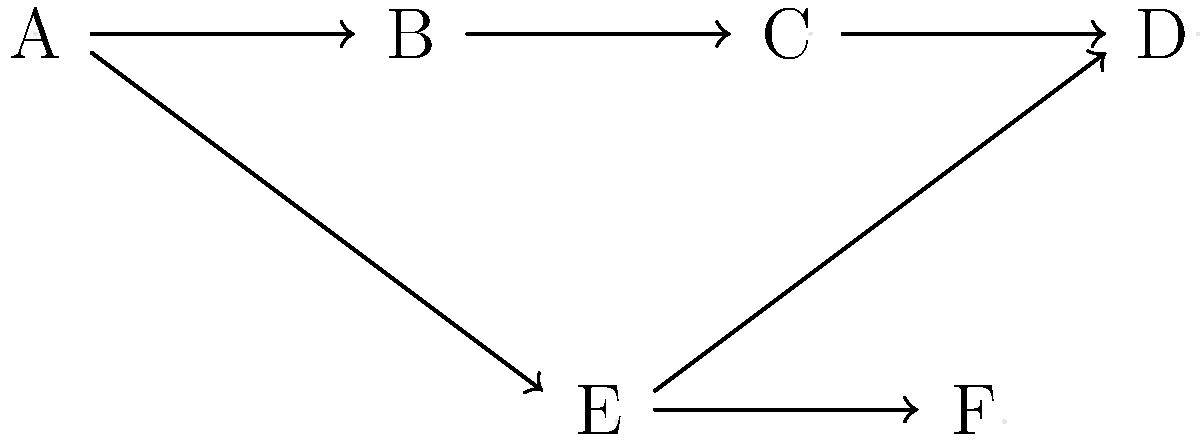As a project manager, you're reviewing the network diagram for a new project. Based on the diagram, which task must be completed before task F can begin? To determine which task must be completed before task F can begin, we need to analyze the dependencies shown in the network diagram. Let's break it down step-by-step:

1. First, we identify that task F has an incoming arrow from task E.
2. This means that task E must be completed before task F can begin.
3. Now, we need to look at the dependencies for task E.
4. We can see that task E has an incoming arrow from task A.
5. This indicates that task A must be completed before task E can start.
6. Since task E depends on task A, and task F depends on task E, we can conclude that task A must be completed before task F can begin.

In project management, this type of dependency is called a "predecessor relationship." Task A is the predecessor of both tasks E and F in this network diagram.

As an empathetic project manager, understanding these dependencies is crucial for:
- Ensuring smooth project flow
- Identifying potential bottlenecks
- Communicating effectively with team members about task priorities
- Maintaining a positive working environment by setting clear expectations

By recognizing that task A must be completed before task F can begin, you can properly sequence the work and allocate resources to keep the project on track.
Answer: Task A 